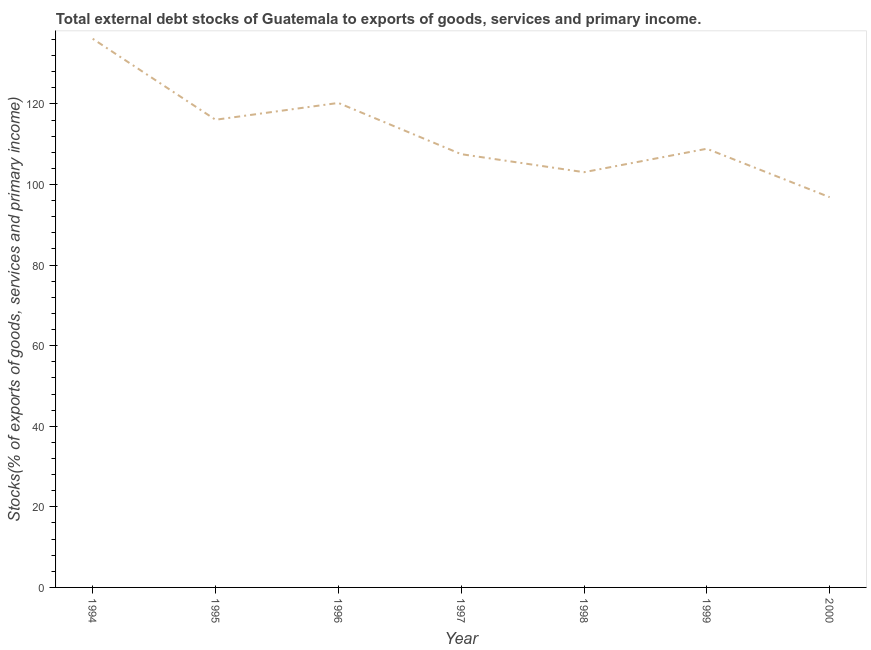What is the external debt stocks in 1998?
Your answer should be compact. 103.05. Across all years, what is the maximum external debt stocks?
Give a very brief answer. 136.17. Across all years, what is the minimum external debt stocks?
Keep it short and to the point. 96.85. In which year was the external debt stocks maximum?
Your answer should be compact. 1994. What is the sum of the external debt stocks?
Your answer should be compact. 788.77. What is the difference between the external debt stocks in 1995 and 2000?
Your answer should be compact. 19.22. What is the average external debt stocks per year?
Your answer should be very brief. 112.68. What is the median external debt stocks?
Provide a short and direct response. 108.87. Do a majority of the years between 1994 and 1997 (inclusive) have external debt stocks greater than 28 %?
Make the answer very short. Yes. What is the ratio of the external debt stocks in 1996 to that in 1997?
Make the answer very short. 1.12. Is the difference between the external debt stocks in 1994 and 1997 greater than the difference between any two years?
Make the answer very short. No. What is the difference between the highest and the second highest external debt stocks?
Make the answer very short. 15.93. Is the sum of the external debt stocks in 1998 and 2000 greater than the maximum external debt stocks across all years?
Give a very brief answer. Yes. What is the difference between the highest and the lowest external debt stocks?
Your answer should be very brief. 39.32. In how many years, is the external debt stocks greater than the average external debt stocks taken over all years?
Provide a succinct answer. 3. How many lines are there?
Offer a very short reply. 1. How many years are there in the graph?
Keep it short and to the point. 7. What is the difference between two consecutive major ticks on the Y-axis?
Your answer should be compact. 20. Does the graph contain any zero values?
Make the answer very short. No. What is the title of the graph?
Keep it short and to the point. Total external debt stocks of Guatemala to exports of goods, services and primary income. What is the label or title of the X-axis?
Give a very brief answer. Year. What is the label or title of the Y-axis?
Ensure brevity in your answer.  Stocks(% of exports of goods, services and primary income). What is the Stocks(% of exports of goods, services and primary income) of 1994?
Offer a very short reply. 136.17. What is the Stocks(% of exports of goods, services and primary income) of 1995?
Provide a short and direct response. 116.07. What is the Stocks(% of exports of goods, services and primary income) of 1996?
Offer a terse response. 120.24. What is the Stocks(% of exports of goods, services and primary income) of 1997?
Make the answer very short. 107.53. What is the Stocks(% of exports of goods, services and primary income) in 1998?
Make the answer very short. 103.05. What is the Stocks(% of exports of goods, services and primary income) in 1999?
Ensure brevity in your answer.  108.87. What is the Stocks(% of exports of goods, services and primary income) of 2000?
Offer a terse response. 96.85. What is the difference between the Stocks(% of exports of goods, services and primary income) in 1994 and 1995?
Your answer should be very brief. 20.1. What is the difference between the Stocks(% of exports of goods, services and primary income) in 1994 and 1996?
Make the answer very short. 15.93. What is the difference between the Stocks(% of exports of goods, services and primary income) in 1994 and 1997?
Keep it short and to the point. 28.64. What is the difference between the Stocks(% of exports of goods, services and primary income) in 1994 and 1998?
Give a very brief answer. 33.12. What is the difference between the Stocks(% of exports of goods, services and primary income) in 1994 and 1999?
Your answer should be compact. 27.3. What is the difference between the Stocks(% of exports of goods, services and primary income) in 1994 and 2000?
Offer a terse response. 39.32. What is the difference between the Stocks(% of exports of goods, services and primary income) in 1995 and 1996?
Give a very brief answer. -4.17. What is the difference between the Stocks(% of exports of goods, services and primary income) in 1995 and 1997?
Provide a short and direct response. 8.54. What is the difference between the Stocks(% of exports of goods, services and primary income) in 1995 and 1998?
Your answer should be very brief. 13.01. What is the difference between the Stocks(% of exports of goods, services and primary income) in 1995 and 1999?
Your answer should be compact. 7.2. What is the difference between the Stocks(% of exports of goods, services and primary income) in 1995 and 2000?
Make the answer very short. 19.22. What is the difference between the Stocks(% of exports of goods, services and primary income) in 1996 and 1997?
Provide a succinct answer. 12.71. What is the difference between the Stocks(% of exports of goods, services and primary income) in 1996 and 1998?
Ensure brevity in your answer.  17.18. What is the difference between the Stocks(% of exports of goods, services and primary income) in 1996 and 1999?
Provide a short and direct response. 11.37. What is the difference between the Stocks(% of exports of goods, services and primary income) in 1996 and 2000?
Your answer should be very brief. 23.39. What is the difference between the Stocks(% of exports of goods, services and primary income) in 1997 and 1998?
Your response must be concise. 4.47. What is the difference between the Stocks(% of exports of goods, services and primary income) in 1997 and 1999?
Your answer should be compact. -1.34. What is the difference between the Stocks(% of exports of goods, services and primary income) in 1997 and 2000?
Provide a short and direct response. 10.68. What is the difference between the Stocks(% of exports of goods, services and primary income) in 1998 and 1999?
Your answer should be compact. -5.82. What is the difference between the Stocks(% of exports of goods, services and primary income) in 1998 and 2000?
Ensure brevity in your answer.  6.21. What is the difference between the Stocks(% of exports of goods, services and primary income) in 1999 and 2000?
Keep it short and to the point. 12.02. What is the ratio of the Stocks(% of exports of goods, services and primary income) in 1994 to that in 1995?
Make the answer very short. 1.17. What is the ratio of the Stocks(% of exports of goods, services and primary income) in 1994 to that in 1996?
Give a very brief answer. 1.13. What is the ratio of the Stocks(% of exports of goods, services and primary income) in 1994 to that in 1997?
Your answer should be compact. 1.27. What is the ratio of the Stocks(% of exports of goods, services and primary income) in 1994 to that in 1998?
Provide a succinct answer. 1.32. What is the ratio of the Stocks(% of exports of goods, services and primary income) in 1994 to that in 1999?
Your answer should be very brief. 1.25. What is the ratio of the Stocks(% of exports of goods, services and primary income) in 1994 to that in 2000?
Your response must be concise. 1.41. What is the ratio of the Stocks(% of exports of goods, services and primary income) in 1995 to that in 1997?
Provide a succinct answer. 1.08. What is the ratio of the Stocks(% of exports of goods, services and primary income) in 1995 to that in 1998?
Offer a terse response. 1.13. What is the ratio of the Stocks(% of exports of goods, services and primary income) in 1995 to that in 1999?
Your answer should be compact. 1.07. What is the ratio of the Stocks(% of exports of goods, services and primary income) in 1995 to that in 2000?
Make the answer very short. 1.2. What is the ratio of the Stocks(% of exports of goods, services and primary income) in 1996 to that in 1997?
Your response must be concise. 1.12. What is the ratio of the Stocks(% of exports of goods, services and primary income) in 1996 to that in 1998?
Provide a succinct answer. 1.17. What is the ratio of the Stocks(% of exports of goods, services and primary income) in 1996 to that in 1999?
Offer a very short reply. 1.1. What is the ratio of the Stocks(% of exports of goods, services and primary income) in 1996 to that in 2000?
Keep it short and to the point. 1.24. What is the ratio of the Stocks(% of exports of goods, services and primary income) in 1997 to that in 1998?
Keep it short and to the point. 1.04. What is the ratio of the Stocks(% of exports of goods, services and primary income) in 1997 to that in 2000?
Ensure brevity in your answer.  1.11. What is the ratio of the Stocks(% of exports of goods, services and primary income) in 1998 to that in 1999?
Make the answer very short. 0.95. What is the ratio of the Stocks(% of exports of goods, services and primary income) in 1998 to that in 2000?
Offer a very short reply. 1.06. What is the ratio of the Stocks(% of exports of goods, services and primary income) in 1999 to that in 2000?
Give a very brief answer. 1.12. 